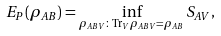Convert formula to latex. <formula><loc_0><loc_0><loc_500><loc_500>E _ { P } ( \rho _ { A B } ) = \inf _ { \rho _ { A B V } \colon \text {Tr} _ { V } \rho _ { A B V } = \rho _ { A B } } S _ { A V } ,</formula> 